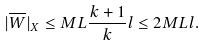Convert formula to latex. <formula><loc_0><loc_0><loc_500><loc_500>| \overline { W } | _ { X } \leq M L \frac { k + 1 } { k } l \leq 2 M L l .</formula> 